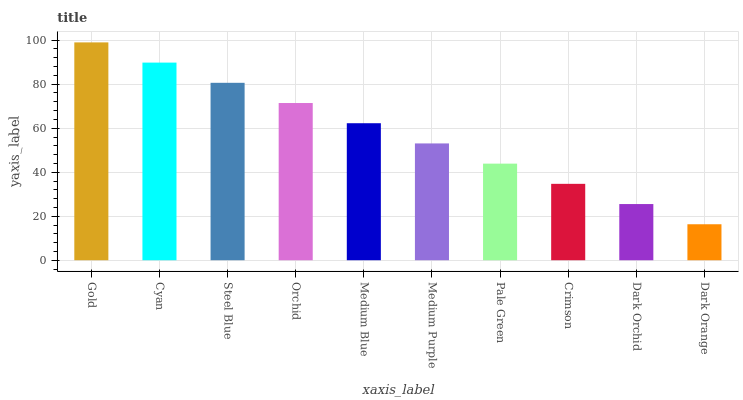Is Dark Orange the minimum?
Answer yes or no. Yes. Is Gold the maximum?
Answer yes or no. Yes. Is Cyan the minimum?
Answer yes or no. No. Is Cyan the maximum?
Answer yes or no. No. Is Gold greater than Cyan?
Answer yes or no. Yes. Is Cyan less than Gold?
Answer yes or no. Yes. Is Cyan greater than Gold?
Answer yes or no. No. Is Gold less than Cyan?
Answer yes or no. No. Is Medium Blue the high median?
Answer yes or no. Yes. Is Medium Purple the low median?
Answer yes or no. Yes. Is Cyan the high median?
Answer yes or no. No. Is Gold the low median?
Answer yes or no. No. 